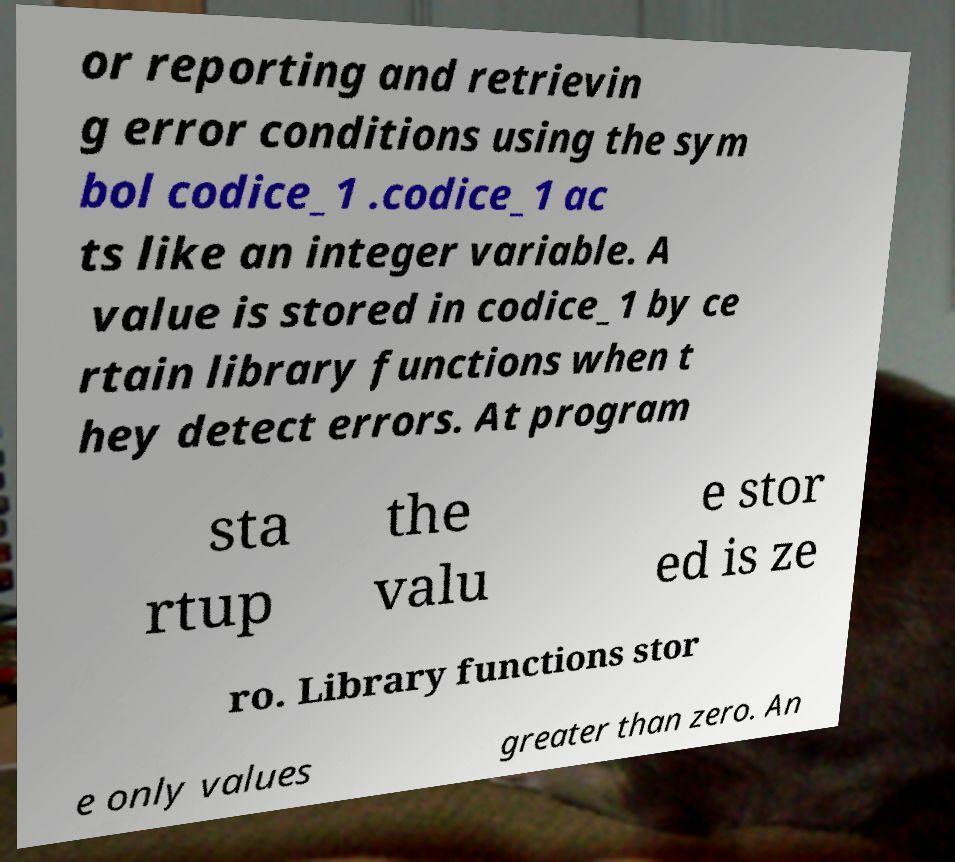Please read and relay the text visible in this image. What does it say? or reporting and retrievin g error conditions using the sym bol codice_1 .codice_1 ac ts like an integer variable. A value is stored in codice_1 by ce rtain library functions when t hey detect errors. At program sta rtup the valu e stor ed is ze ro. Library functions stor e only values greater than zero. An 